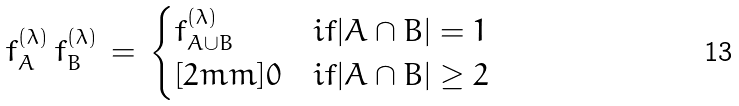Convert formula to latex. <formula><loc_0><loc_0><loc_500><loc_500>f _ { A } ^ { ( \lambda ) } \, f _ { B } ^ { ( \lambda ) } \, = \, \begin{cases} f _ { A \cup B } ^ { ( \lambda ) } & i f | A \cap B | = 1 \\ [ 2 m m ] 0 & i f | A \cap B | \geq 2 \end{cases}</formula> 